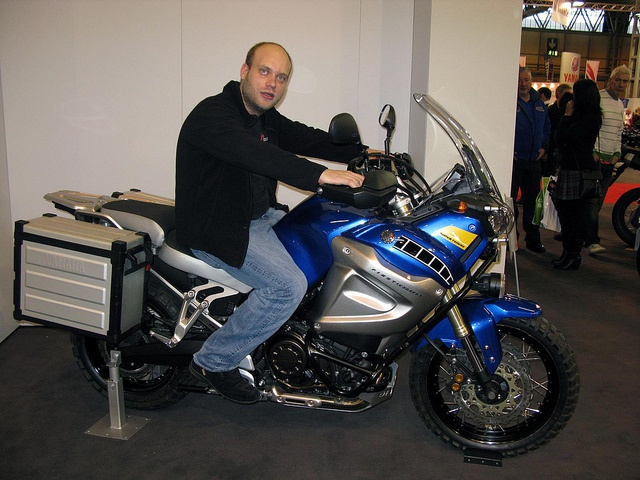Describe the objects in this image and their specific colors. I can see motorcycle in gray, black, darkgray, and navy tones, people in gray, black, and blue tones, people in gray, black, maroon, and darkgreen tones, people in gray, black, maroon, olive, and darkgreen tones, and people in gray, black, and maroon tones in this image. 